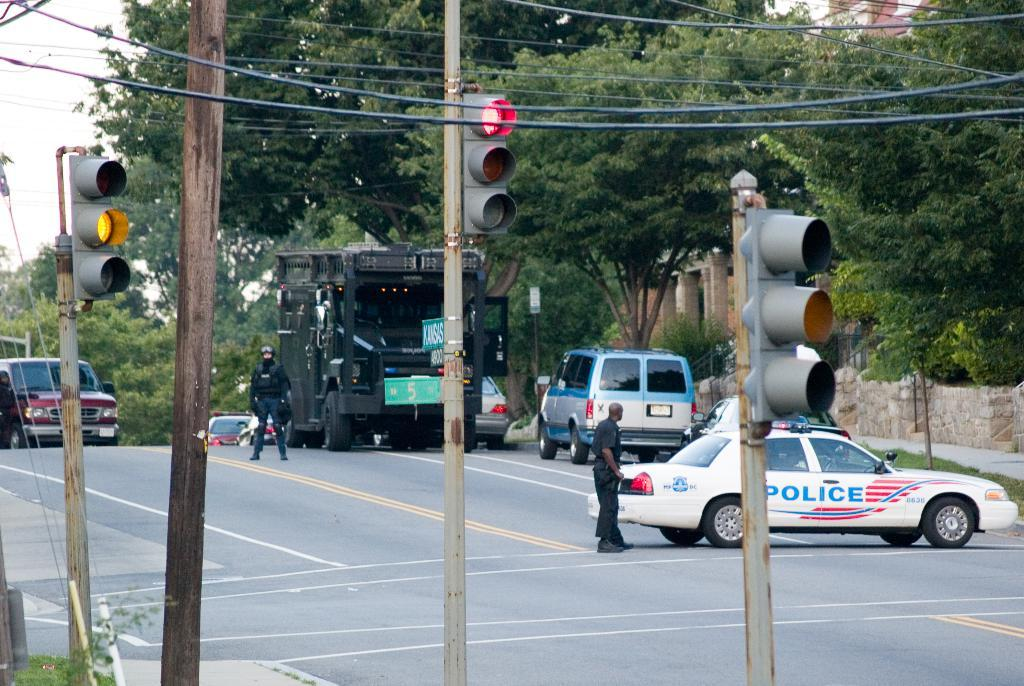<image>
Describe the image concisely. A white blue and red police car in the middle of the empty road 